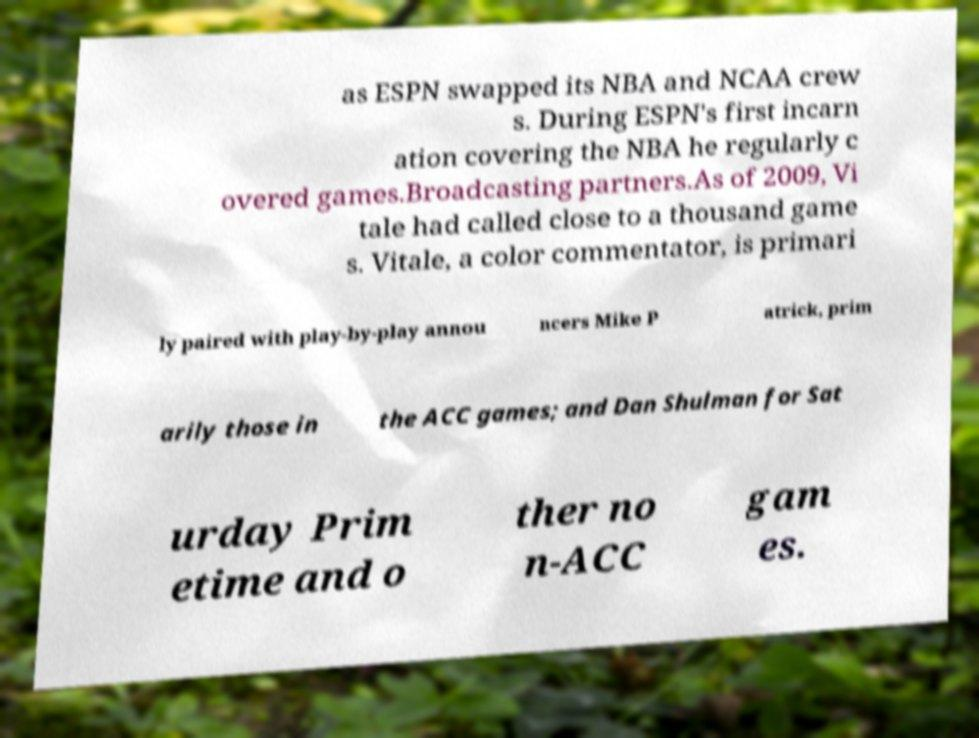Could you assist in decoding the text presented in this image and type it out clearly? as ESPN swapped its NBA and NCAA crew s. During ESPN's first incarn ation covering the NBA he regularly c overed games.Broadcasting partners.As of 2009, Vi tale had called close to a thousand game s. Vitale, a color commentator, is primari ly paired with play-by-play annou ncers Mike P atrick, prim arily those in the ACC games; and Dan Shulman for Sat urday Prim etime and o ther no n-ACC gam es. 